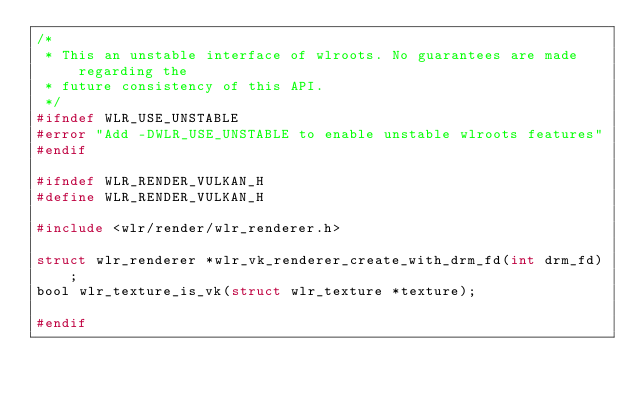Convert code to text. <code><loc_0><loc_0><loc_500><loc_500><_C_>/*
 * This an unstable interface of wlroots. No guarantees are made regarding the
 * future consistency of this API.
 */
#ifndef WLR_USE_UNSTABLE
#error "Add -DWLR_USE_UNSTABLE to enable unstable wlroots features"
#endif

#ifndef WLR_RENDER_VULKAN_H
#define WLR_RENDER_VULKAN_H

#include <wlr/render/wlr_renderer.h>

struct wlr_renderer *wlr_vk_renderer_create_with_drm_fd(int drm_fd);
bool wlr_texture_is_vk(struct wlr_texture *texture);

#endif

</code> 